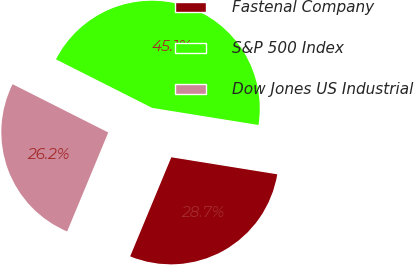Convert chart to OTSL. <chart><loc_0><loc_0><loc_500><loc_500><pie_chart><fcel>Fastenal Company<fcel>S&P 500 Index<fcel>Dow Jones US Industrial<nl><fcel>28.73%<fcel>45.1%<fcel>26.17%<nl></chart> 